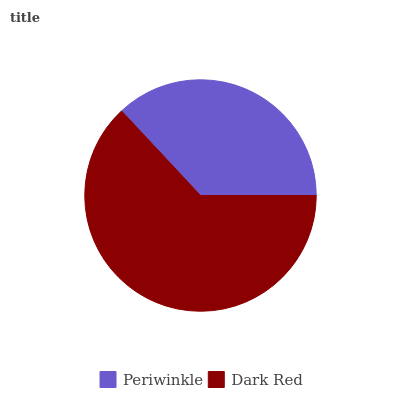Is Periwinkle the minimum?
Answer yes or no. Yes. Is Dark Red the maximum?
Answer yes or no. Yes. Is Dark Red the minimum?
Answer yes or no. No. Is Dark Red greater than Periwinkle?
Answer yes or no. Yes. Is Periwinkle less than Dark Red?
Answer yes or no. Yes. Is Periwinkle greater than Dark Red?
Answer yes or no. No. Is Dark Red less than Periwinkle?
Answer yes or no. No. Is Dark Red the high median?
Answer yes or no. Yes. Is Periwinkle the low median?
Answer yes or no. Yes. Is Periwinkle the high median?
Answer yes or no. No. Is Dark Red the low median?
Answer yes or no. No. 